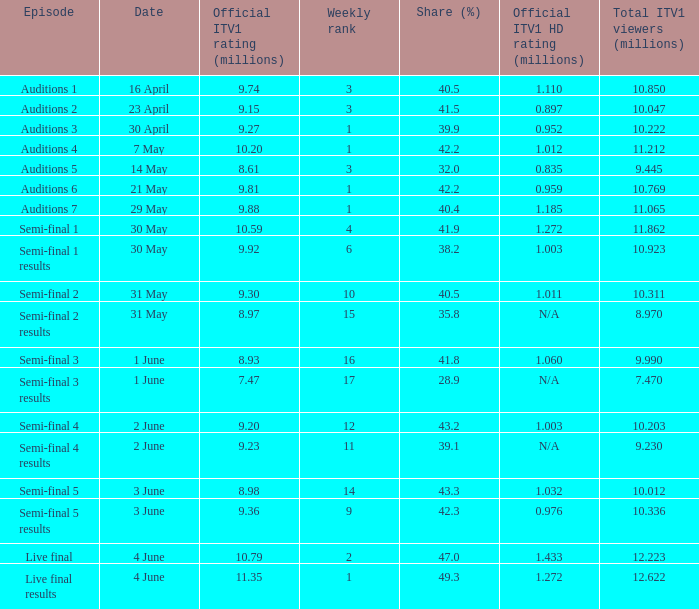When was the episode that had a share (%) of 41.5? 23 April. 